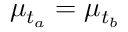Convert formula to latex. <formula><loc_0><loc_0><loc_500><loc_500>\mu _ { t _ { a } } = \mu _ { t _ { b } }</formula> 